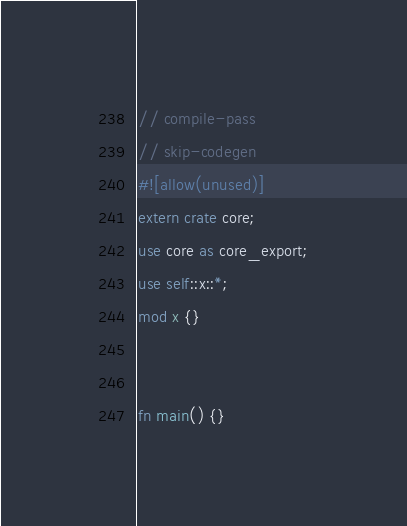Convert code to text. <code><loc_0><loc_0><loc_500><loc_500><_Rust_>// compile-pass
// skip-codegen
#![allow(unused)]
extern crate core;
use core as core_export;
use self::x::*;
mod x {}


fn main() {}
</code> 